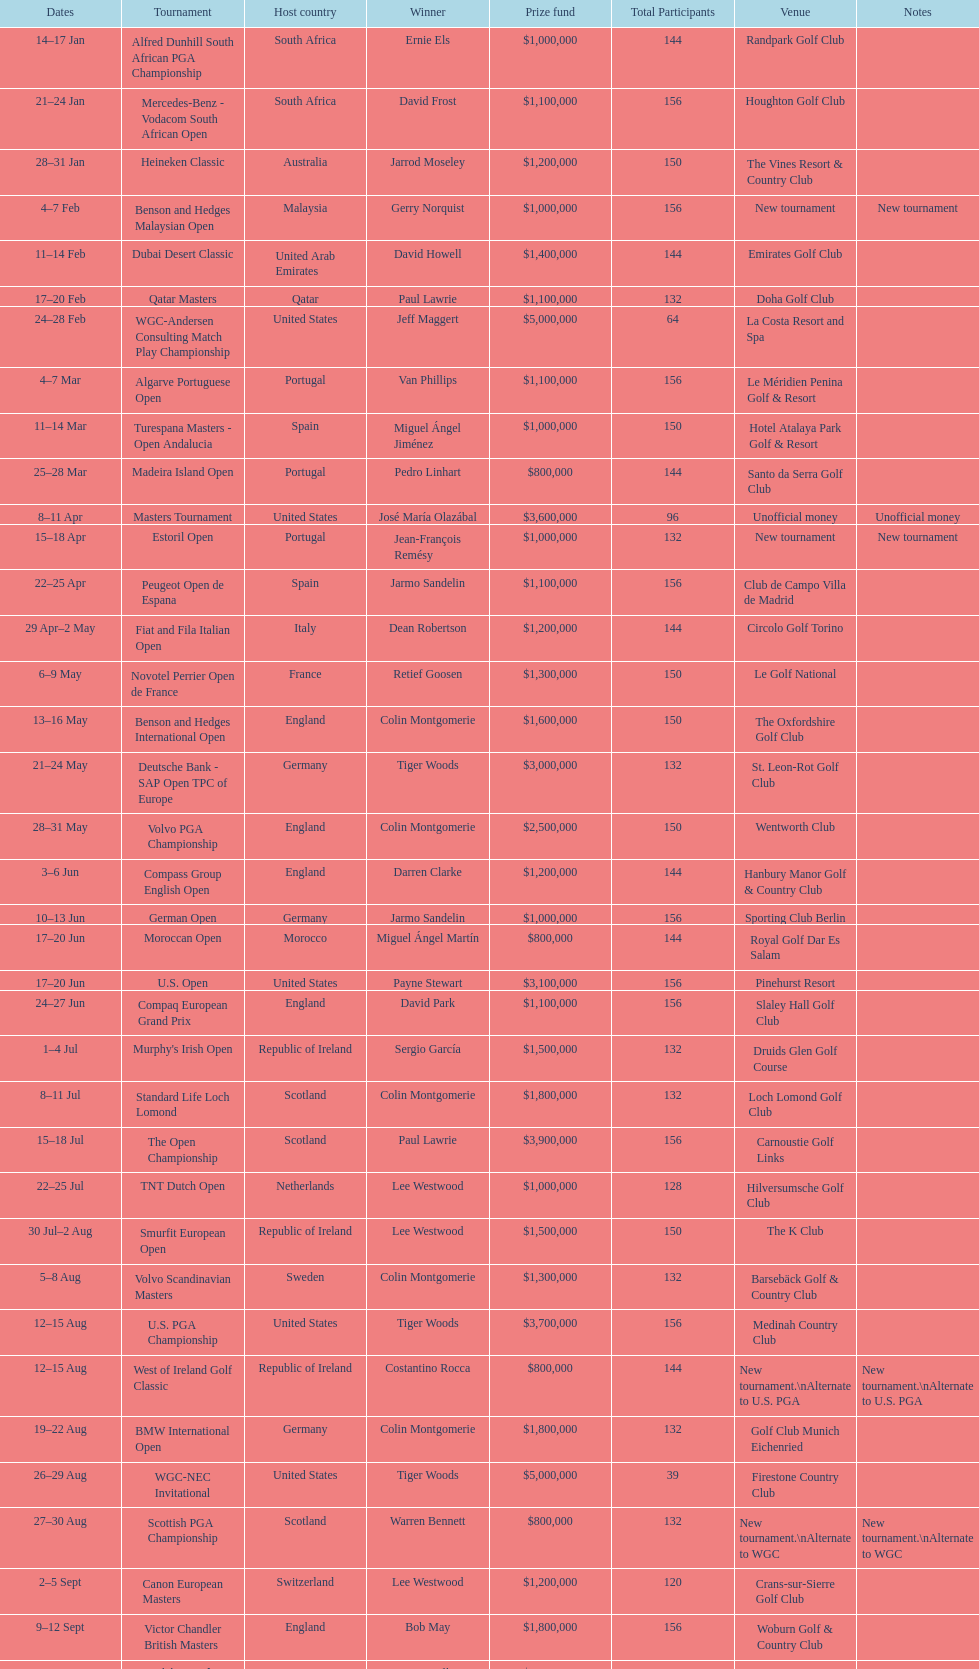How many consecutive times was south africa the host country? 2. 